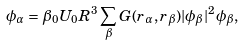Convert formula to latex. <formula><loc_0><loc_0><loc_500><loc_500>\phi _ { \alpha } = \beta _ { 0 } U _ { 0 } R ^ { 3 } \sum _ { \beta } G ( { r } _ { \alpha } , { r } _ { \beta } ) | \phi _ { \beta } | ^ { 2 } \phi _ { \beta } ,</formula> 